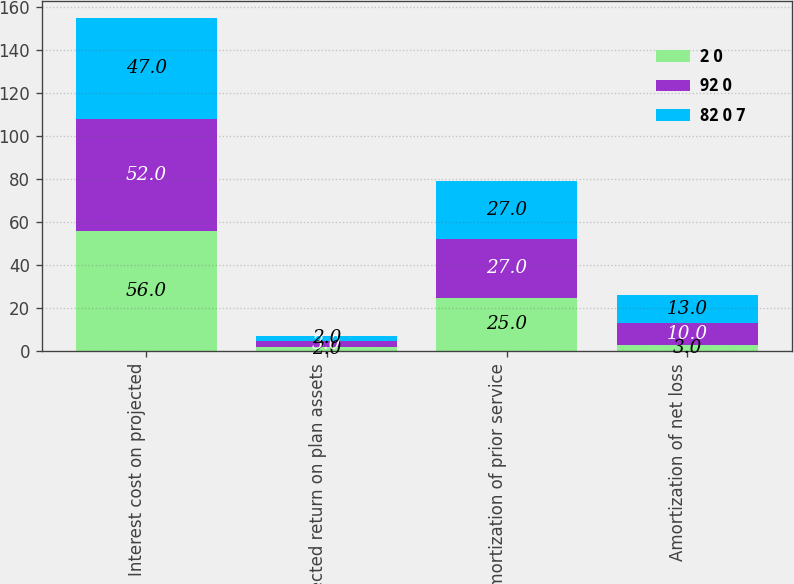Convert chart. <chart><loc_0><loc_0><loc_500><loc_500><stacked_bar_chart><ecel><fcel>Interest cost on projected<fcel>Expected return on plan assets<fcel>Amortization of prior service<fcel>Amortization of net loss<nl><fcel>2 0<fcel>56<fcel>2<fcel>25<fcel>3<nl><fcel>92 0<fcel>52<fcel>3<fcel>27<fcel>10<nl><fcel>82 0 7<fcel>47<fcel>2<fcel>27<fcel>13<nl></chart> 